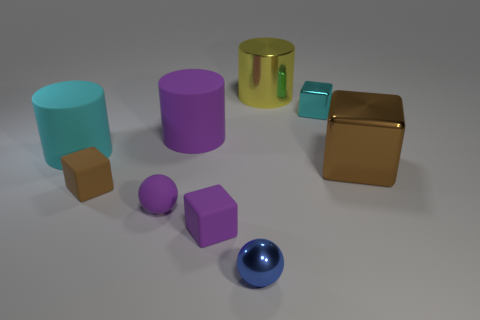Add 1 red cubes. How many objects exist? 10 Subtract all balls. How many objects are left? 7 Subtract 2 brown blocks. How many objects are left? 7 Subtract all purple matte blocks. Subtract all big brown matte objects. How many objects are left? 8 Add 6 big cyan cylinders. How many big cyan cylinders are left? 7 Add 2 large red shiny cubes. How many large red shiny cubes exist? 2 